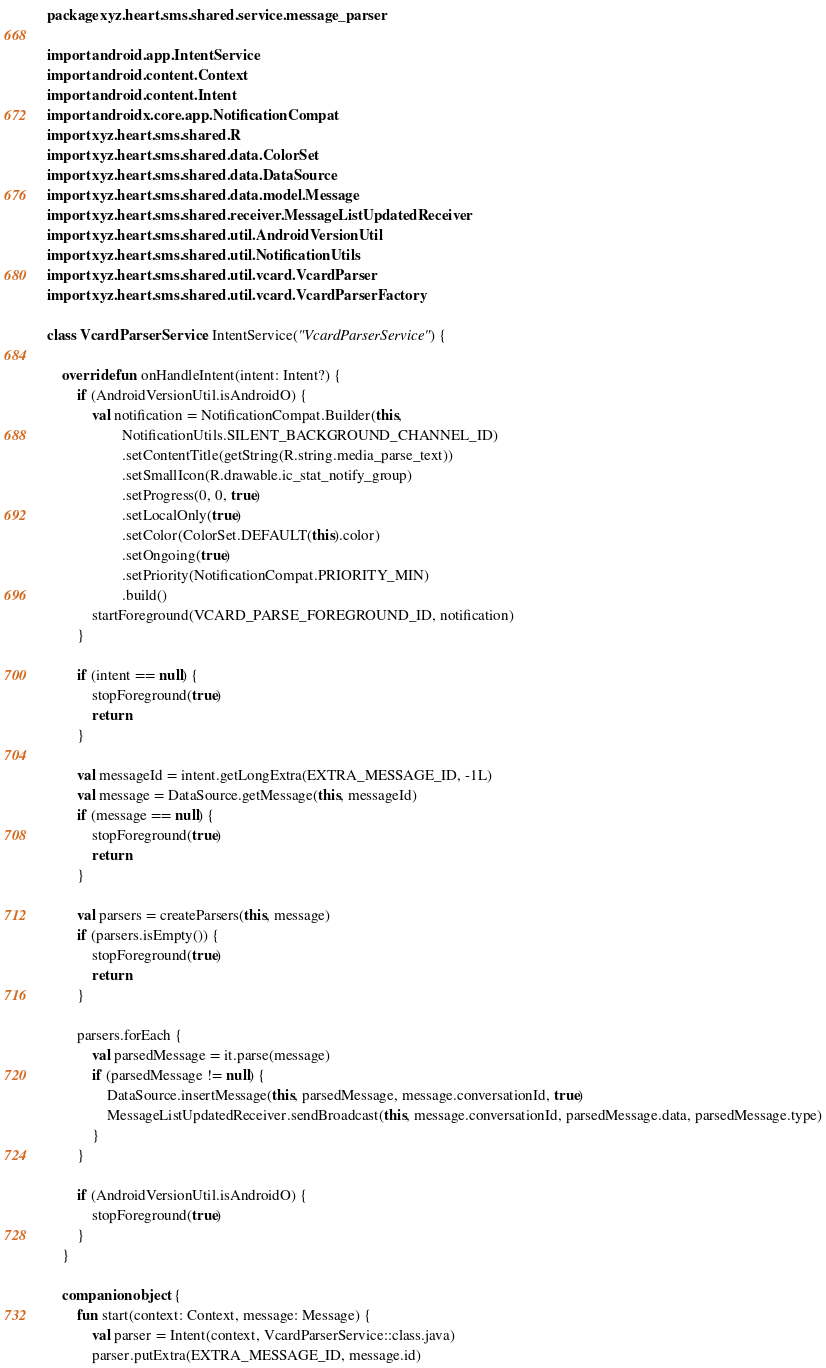<code> <loc_0><loc_0><loc_500><loc_500><_Kotlin_>package xyz.heart.sms.shared.service.message_parser

import android.app.IntentService
import android.content.Context
import android.content.Intent
import androidx.core.app.NotificationCompat
import xyz.heart.sms.shared.R
import xyz.heart.sms.shared.data.ColorSet
import xyz.heart.sms.shared.data.DataSource
import xyz.heart.sms.shared.data.model.Message
import xyz.heart.sms.shared.receiver.MessageListUpdatedReceiver
import xyz.heart.sms.shared.util.AndroidVersionUtil
import xyz.heart.sms.shared.util.NotificationUtils
import xyz.heart.sms.shared.util.vcard.VcardParser
import xyz.heart.sms.shared.util.vcard.VcardParserFactory

class VcardParserService : IntentService("VcardParserService") {

    override fun onHandleIntent(intent: Intent?) {
        if (AndroidVersionUtil.isAndroidO) {
            val notification = NotificationCompat.Builder(this,
                    NotificationUtils.SILENT_BACKGROUND_CHANNEL_ID)
                    .setContentTitle(getString(R.string.media_parse_text))
                    .setSmallIcon(R.drawable.ic_stat_notify_group)
                    .setProgress(0, 0, true)
                    .setLocalOnly(true)
                    .setColor(ColorSet.DEFAULT(this).color)
                    .setOngoing(true)
                    .setPriority(NotificationCompat.PRIORITY_MIN)
                    .build()
            startForeground(VCARD_PARSE_FOREGROUND_ID, notification)
        }

        if (intent == null) {
            stopForeground(true)
            return
        }

        val messageId = intent.getLongExtra(EXTRA_MESSAGE_ID, -1L)
        val message = DataSource.getMessage(this, messageId)
        if (message == null) {
            stopForeground(true)
            return
        }

        val parsers = createParsers(this, message)
        if (parsers.isEmpty()) {
            stopForeground(true)
            return
        }

        parsers.forEach {
            val parsedMessage = it.parse(message)
            if (parsedMessage != null) {
                DataSource.insertMessage(this, parsedMessage, message.conversationId, true)
                MessageListUpdatedReceiver.sendBroadcast(this, message.conversationId, parsedMessage.data, parsedMessage.type)
            }
        }

        if (AndroidVersionUtil.isAndroidO) {
            stopForeground(true)
        }
    }

    companion object {
        fun start(context: Context, message: Message) {
            val parser = Intent(context, VcardParserService::class.java)
            parser.putExtra(EXTRA_MESSAGE_ID, message.id)
</code> 